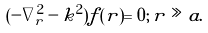<formula> <loc_0><loc_0><loc_500><loc_500>( - \nabla _ { r } ^ { 2 } - k ^ { 2 } ) f ( { r } ) = 0 ; \, r \gg a .</formula> 